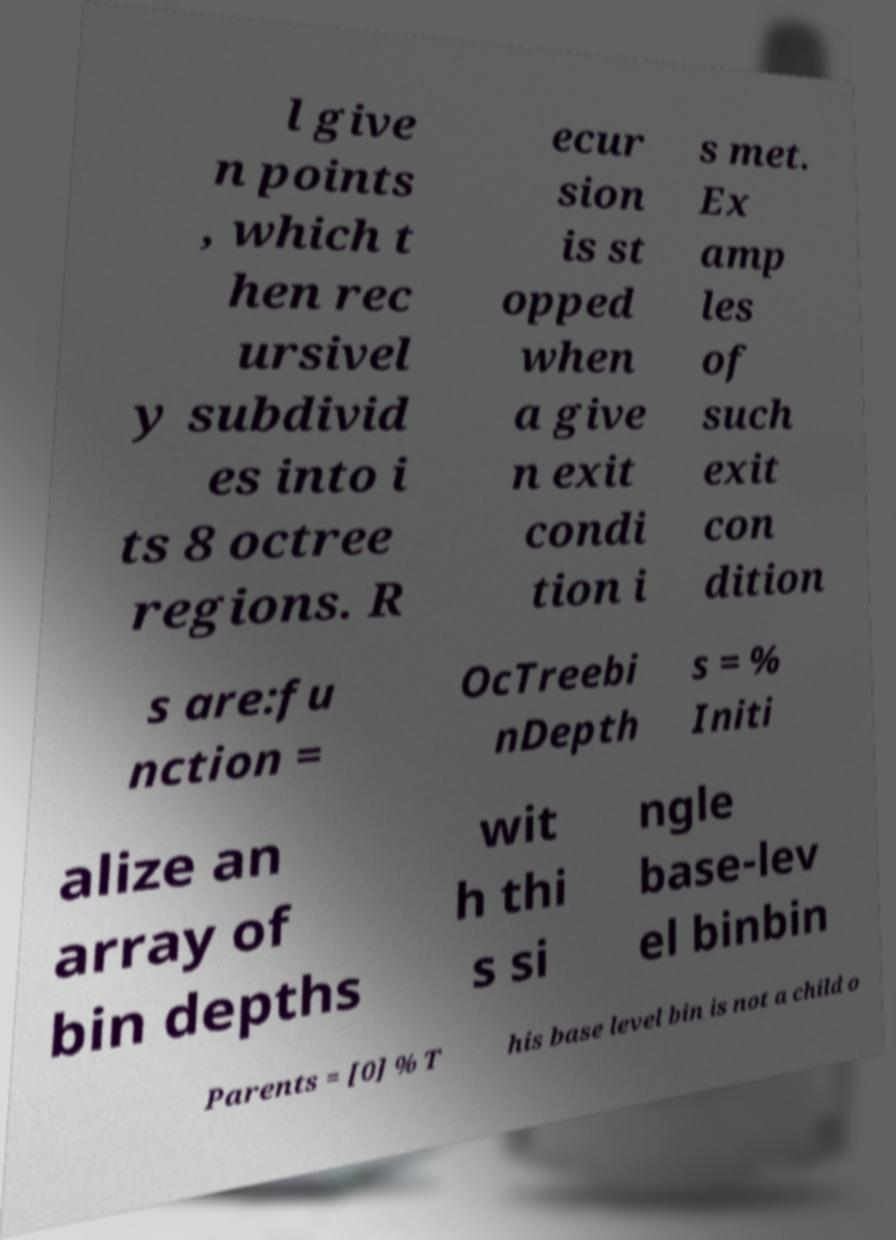Please identify and transcribe the text found in this image. l give n points , which t hen rec ursivel y subdivid es into i ts 8 octree regions. R ecur sion is st opped when a give n exit condi tion i s met. Ex amp les of such exit con dition s are:fu nction = OcTreebi nDepth s = % Initi alize an array of bin depths wit h thi s si ngle base-lev el binbin Parents = [0] % T his base level bin is not a child o 